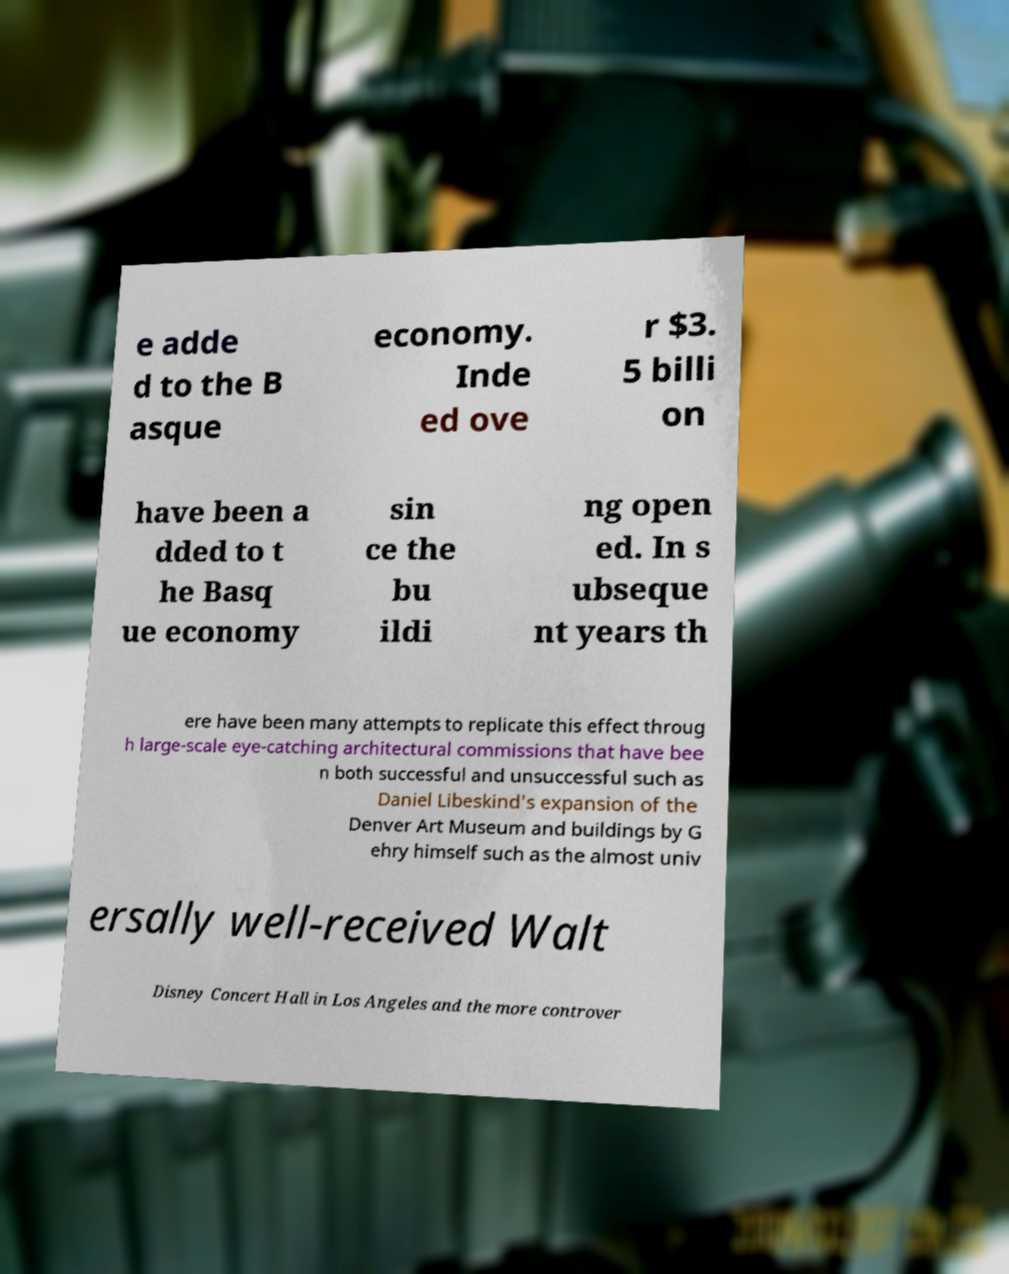For documentation purposes, I need the text within this image transcribed. Could you provide that? e adde d to the B asque economy. Inde ed ove r $3. 5 billi on have been a dded to t he Basq ue economy sin ce the bu ildi ng open ed. In s ubseque nt years th ere have been many attempts to replicate this effect throug h large-scale eye-catching architectural commissions that have bee n both successful and unsuccessful such as Daniel Libeskind's expansion of the Denver Art Museum and buildings by G ehry himself such as the almost univ ersally well-received Walt Disney Concert Hall in Los Angeles and the more controver 